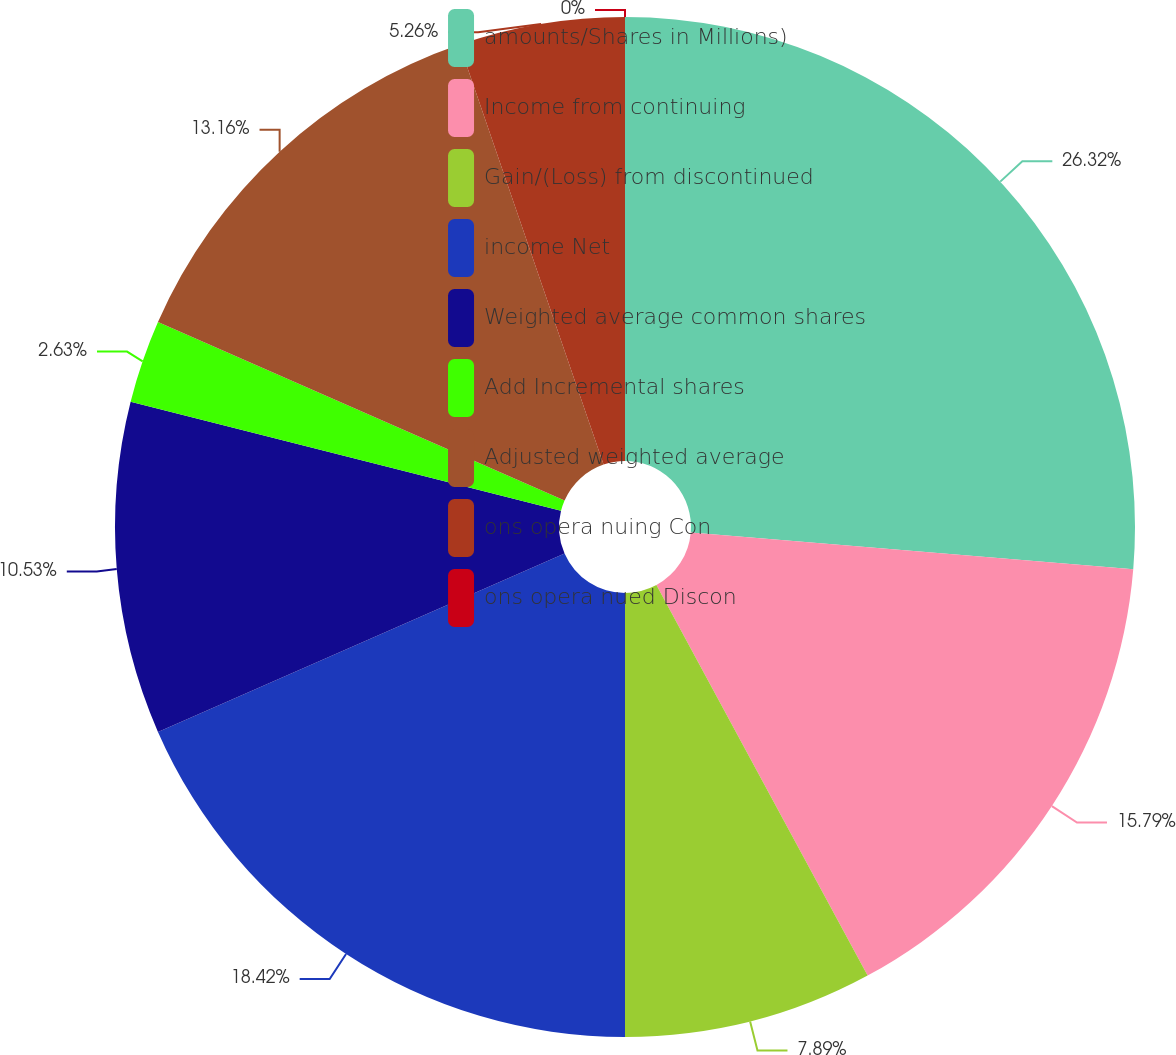<chart> <loc_0><loc_0><loc_500><loc_500><pie_chart><fcel>amounts/Shares in Millions)<fcel>Income from continuing<fcel>Gain/(Loss) from discontinued<fcel>income Net<fcel>Weighted average common shares<fcel>Add Incremental shares<fcel>Adjusted weighted average<fcel>ons opera nuing Con<fcel>ons opera nued Discon<nl><fcel>26.32%<fcel>15.79%<fcel>7.89%<fcel>18.42%<fcel>10.53%<fcel>2.63%<fcel>13.16%<fcel>5.26%<fcel>0.0%<nl></chart> 